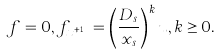Convert formula to latex. <formula><loc_0><loc_0><loc_500><loc_500>f = 0 , f _ { x ^ { k + 1 } } = \left ( \frac { D _ { s } } { x _ { s } } \right ) ^ { k } u , k \geq 0 .</formula> 